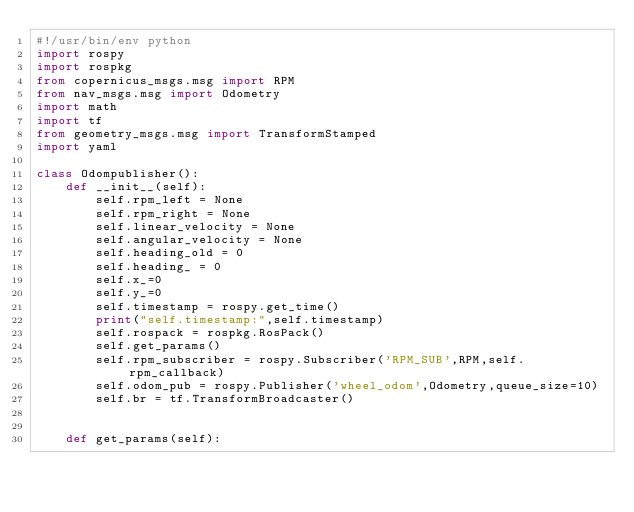<code> <loc_0><loc_0><loc_500><loc_500><_Python_>#!/usr/bin/env python
import rospy
import rospkg
from copernicus_msgs.msg import RPM
from nav_msgs.msg import Odometry
import math
import tf
from geometry_msgs.msg import TransformStamped
import yaml

class Odompublisher():
    def __init__(self):
        self.rpm_left = None
        self.rpm_right = None
        self.linear_velocity = None
        self.angular_velocity = None
        self.heading_old = 0
        self.heading_ = 0
        self.x_=0
        self.y_=0
        self.timestamp = rospy.get_time()
        print("self.timestamp:",self.timestamp)
        self.rospack = rospkg.RosPack()
        self.get_params()
        self.rpm_subscriber = rospy.Subscriber('RPM_SUB',RPM,self.rpm_callback)
        self.odom_pub = rospy.Publisher('wheel_odom',Odometry,queue_size=10)
        self.br = tf.TransformBroadcaster()
        
    
    def get_params(self):</code> 